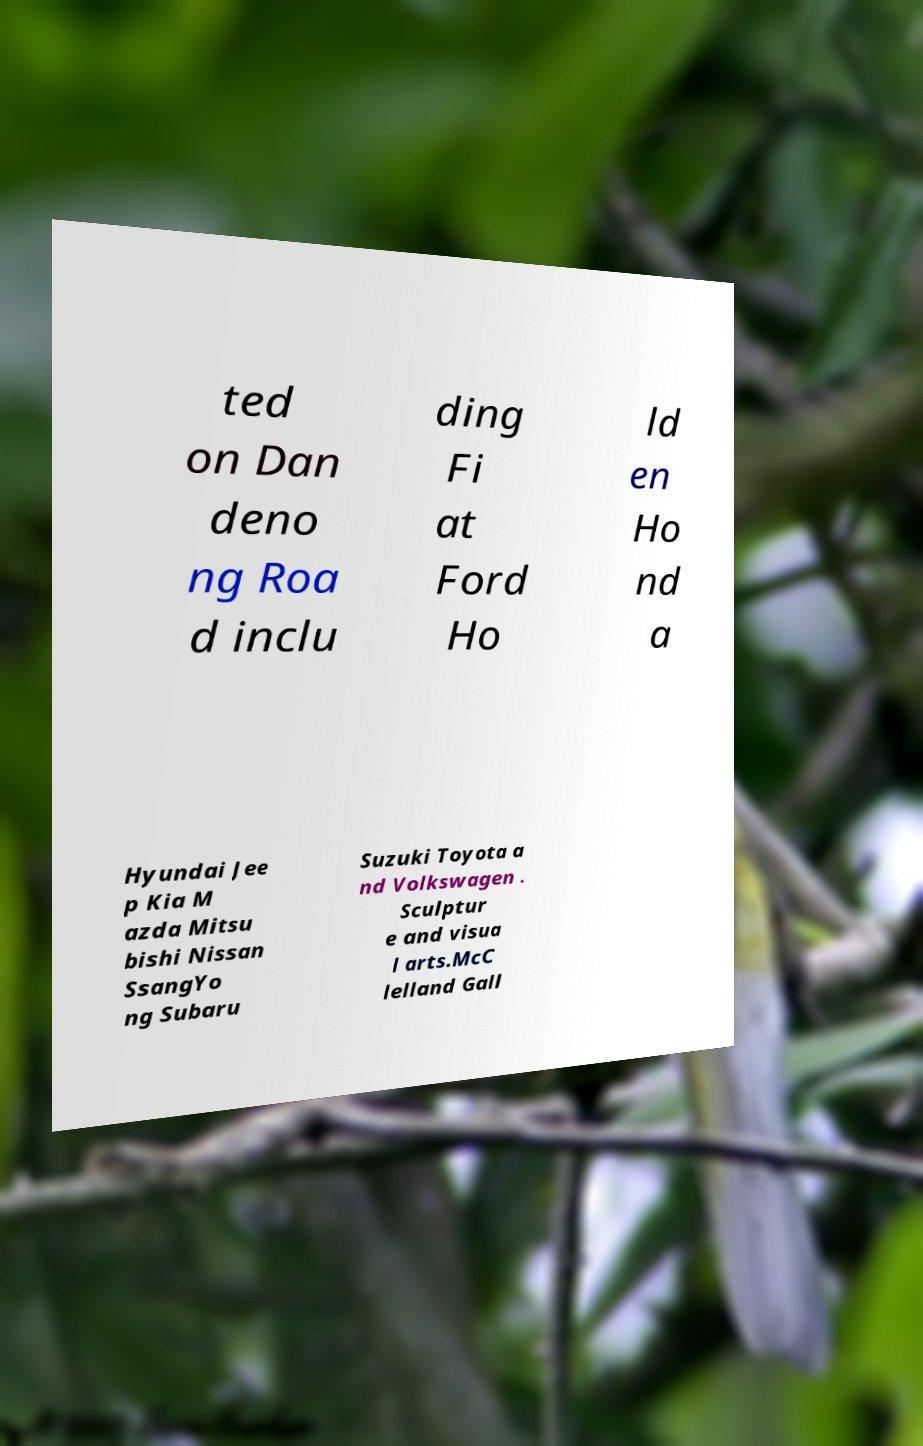There's text embedded in this image that I need extracted. Can you transcribe it verbatim? ted on Dan deno ng Roa d inclu ding Fi at Ford Ho ld en Ho nd a Hyundai Jee p Kia M azda Mitsu bishi Nissan SsangYo ng Subaru Suzuki Toyota a nd Volkswagen . Sculptur e and visua l arts.McC lelland Gall 